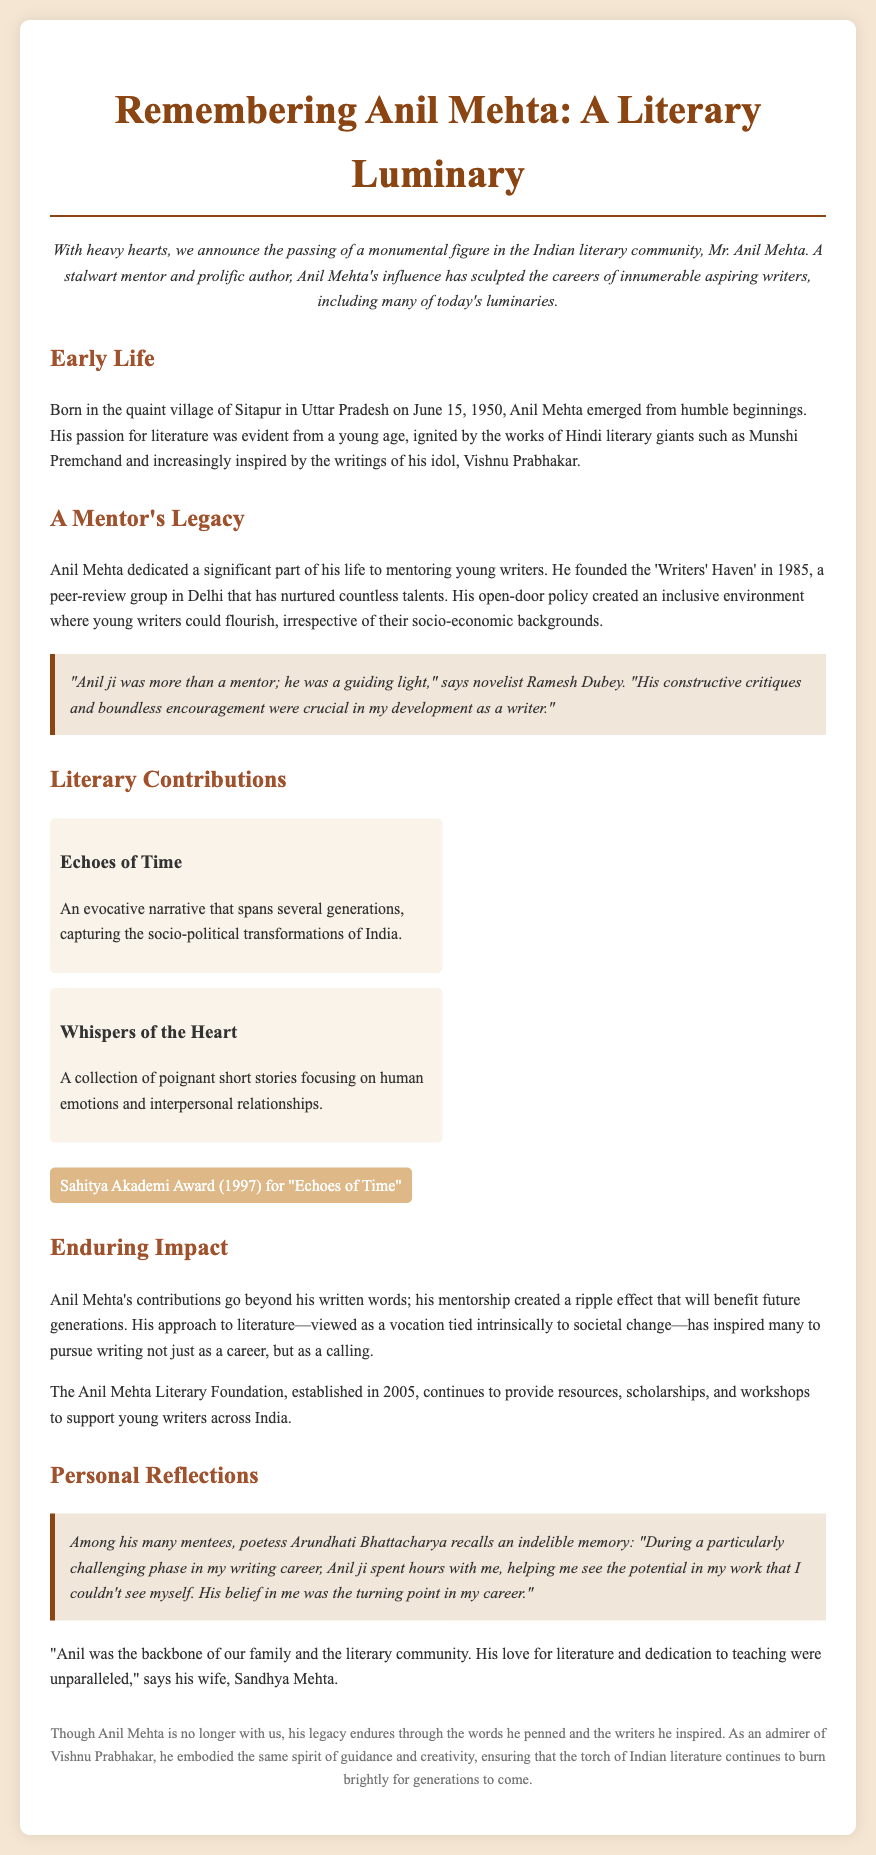what is the name of the literary figure being remembered? The obituary is focused on Anil Mehta, a significant figure in the literary community.
Answer: Anil Mehta when was Anil Mehta born? The document mentions that Anil Mehta was born on June 15, 1950.
Answer: June 15, 1950 what notable award did Anil Mehta receive? The document states that Anil Mehta received the Sahitya Akademi Award in 1997 for one of his works.
Answer: Sahitya Akademi Award what is the title of Anil Mehta's evocative narrative? The obituary lists "Echoes of Time" as one of his notable works.
Answer: Echoes of Time what did Anil Mehta found in 1985? The document indicates that Anil Mehta founded the 'Writers' Haven' in 1985 to mentor young writers.
Answer: Writers' Haven how does the document describe Anil Mehta's approach to literature? It is mentioned that Anil Mehta viewed literature as a vocation tied intrinsically to societal change.
Answer: A vocation tied intrinsically to societal change who recalled Anil Mehta spending hours with her during a challenging phase? Poetess Arundhati Bhattacharya is mentioned as recalling this memory about Anil Mehta.
Answer: Arundhati Bhattacharya which village was Anil Mehta born in? The obituary notes that he was born in the village of Sitapur in Uttar Pradesh.
Answer: Sitapur 